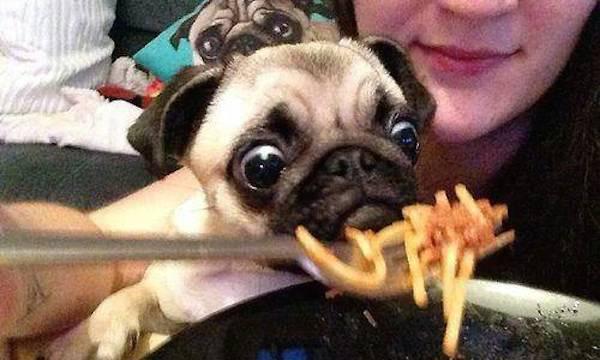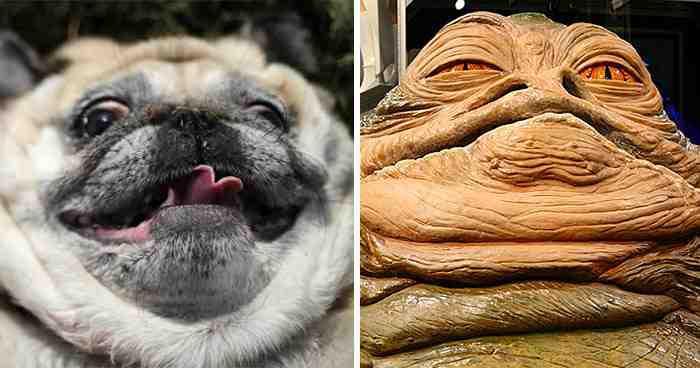The first image is the image on the left, the second image is the image on the right. Assess this claim about the two images: "The dog in the image on the left is sitting before a white plate of food.". Correct or not? Answer yes or no. No. 